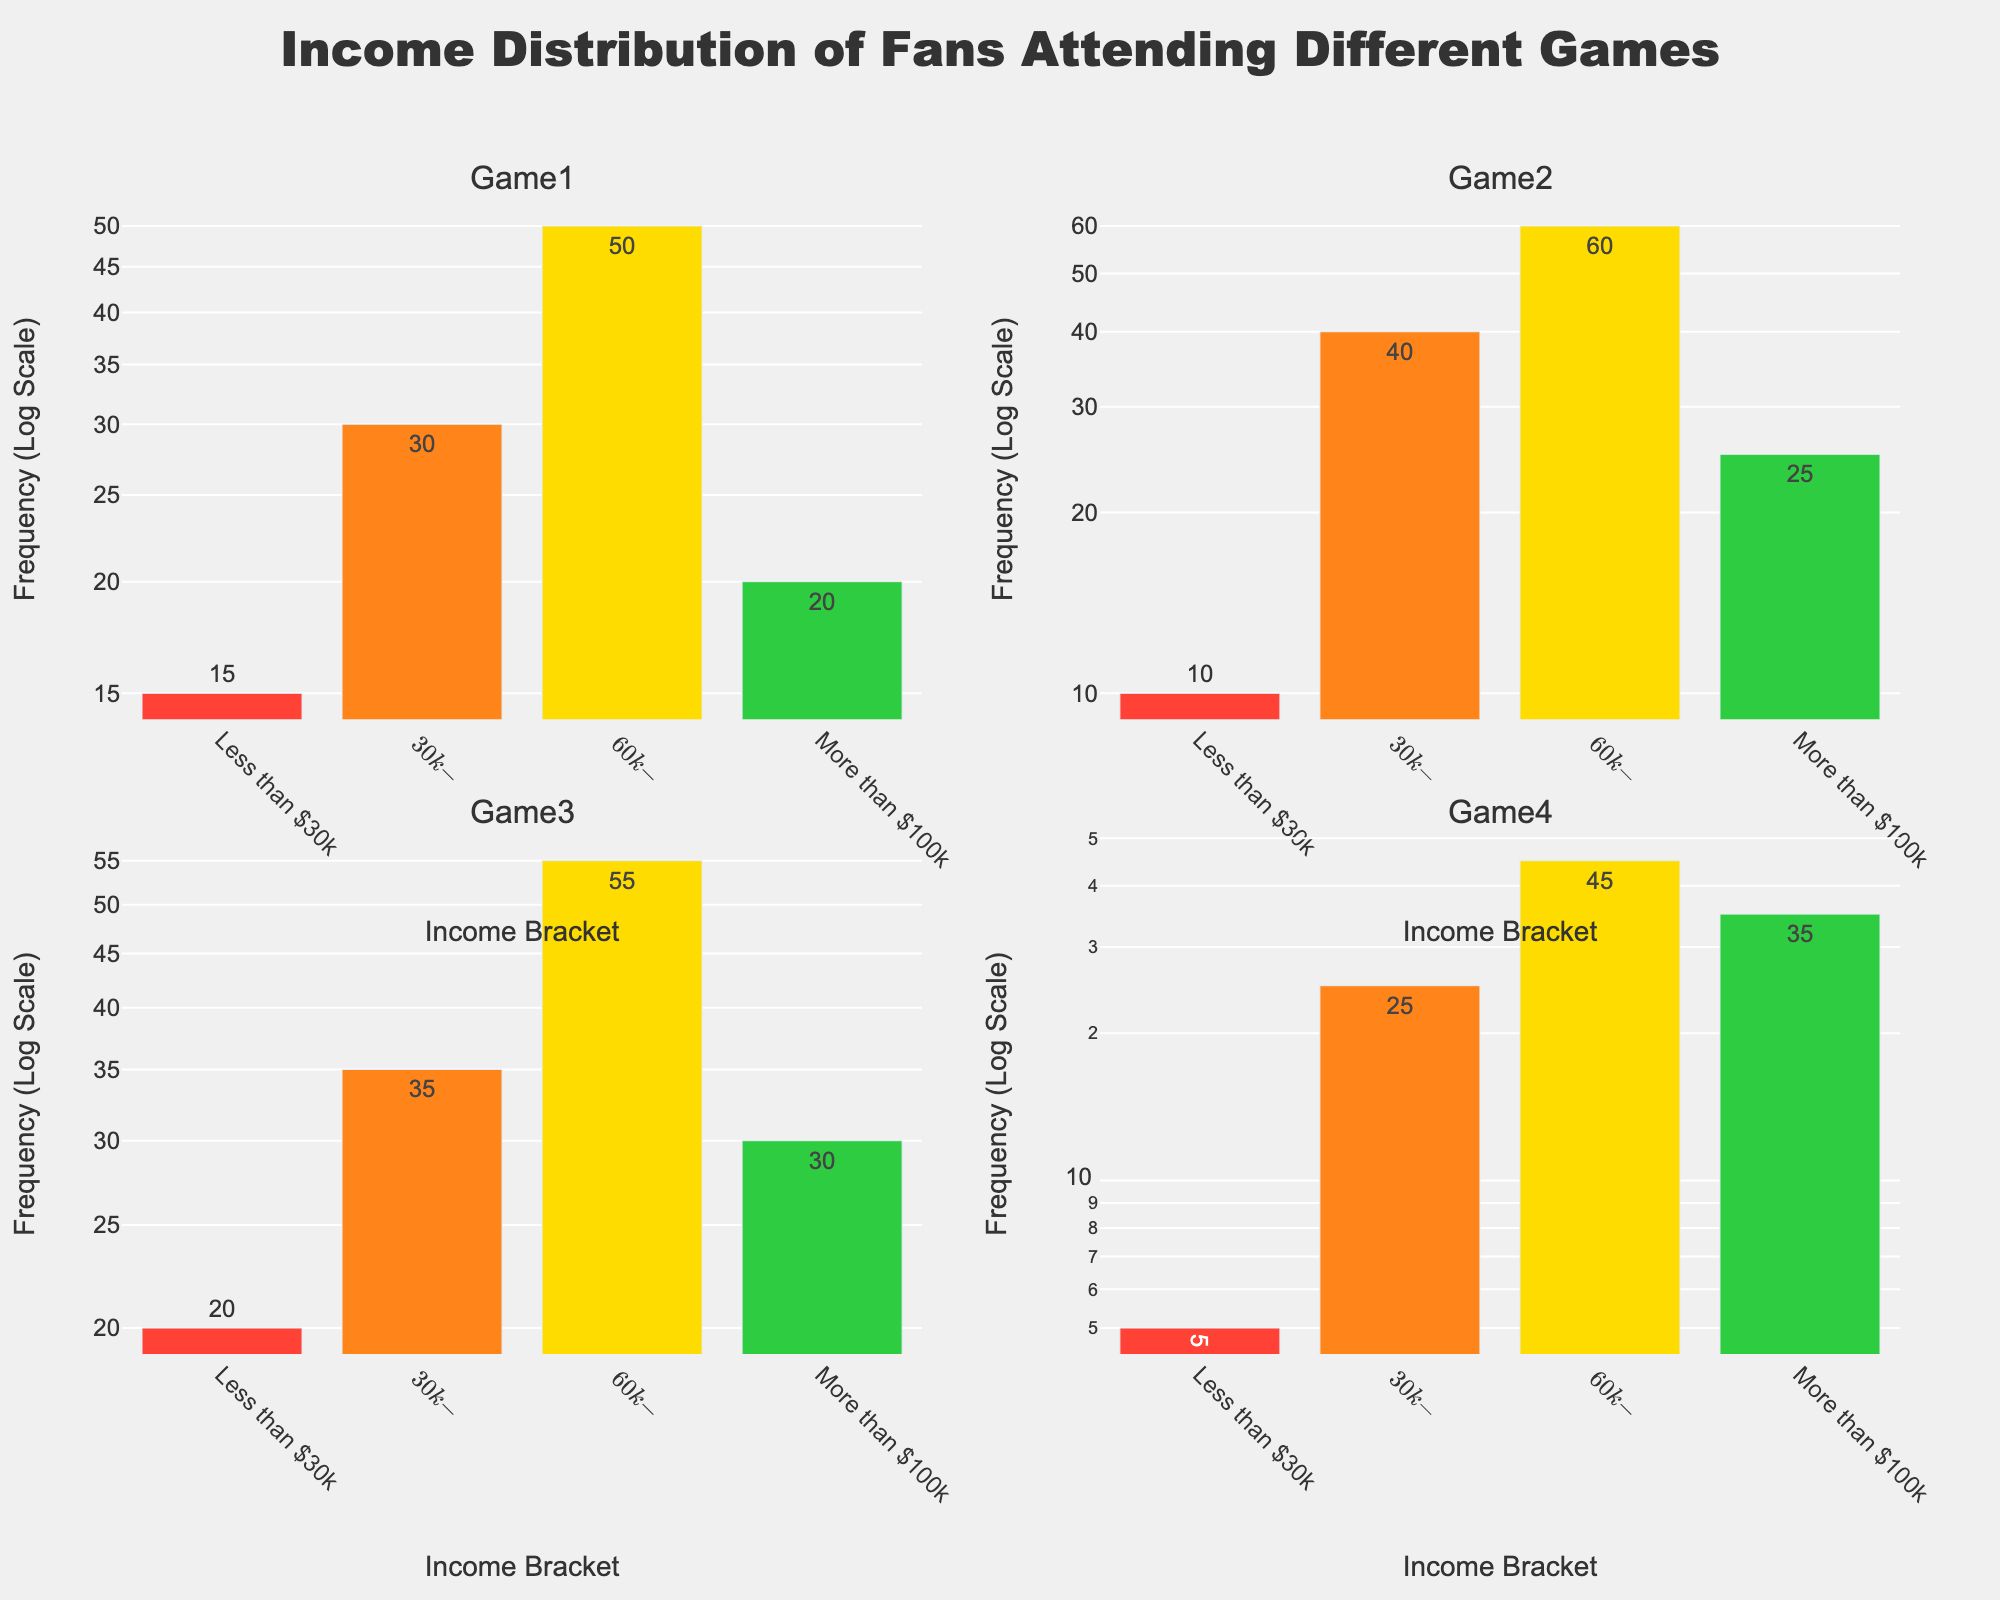What's the title of the plot? The title is located at the top of the plot panel, centered with emphasized formatting. It reads: "Income Distribution of Fans Attending Different Games."
Answer: Income Distribution of Fans Attending Different Games Which Game has the highest frequency of fans with an income of $60k-$100k? Reviewing the subplots, Game 2 has the tallest bar for the $60k-$100k income bracket, indicating the highest frequency.
Answer: Game 2 What is the frequency of fans earning more than $100k for Game 4? Looking at the bar for Game 4 under the "More than $100k" income category, the bar label indicates 35.
Answer: 35 How does the frequency of fans earning less than $30k compare between Game 1 and Game 3? The bar heights for the "Less than $30k" category show Game 1 at 15 and Game 3 at 20. 20 is greater than 15, indicating more fans earning less than $30k for Game 3.
Answer: Game 3 has more Which income bracket shows the most significant variation across all games? The income bracket $60k-$100k shows the most considerable variation, as the frequency ranges from 45 to 60, the highest spread among all games.
Answer: $60k-$100k What's the average frequency of fans in the $30k-$60k income bracket across all games? The frequencies for the $30k-$60k bracket are 30, 40, 35, and 25. Summing these values gives 130. Dividing by the number of games (4) yields 32.5.
Answer: 32.5 Which game has the lowest frequency of fans in the "Less than $30k" income bracket, and what is that frequency? Among all the subplots, Game 4's "Less than $30k" bar is the shortest, corresponding to a frequency of 5.
Answer: Game 4, frequency 5 Is there any game where the frequency of fans in the "More than $100k" bracket exceeds those earning "$60k-$100k"? Comparing the bar heights in all subplots for "$60k-$100k" and "More than $100k," no game shows the "More than $100k" bar higher than the "$60k-$100k" bar.
Answer: No 